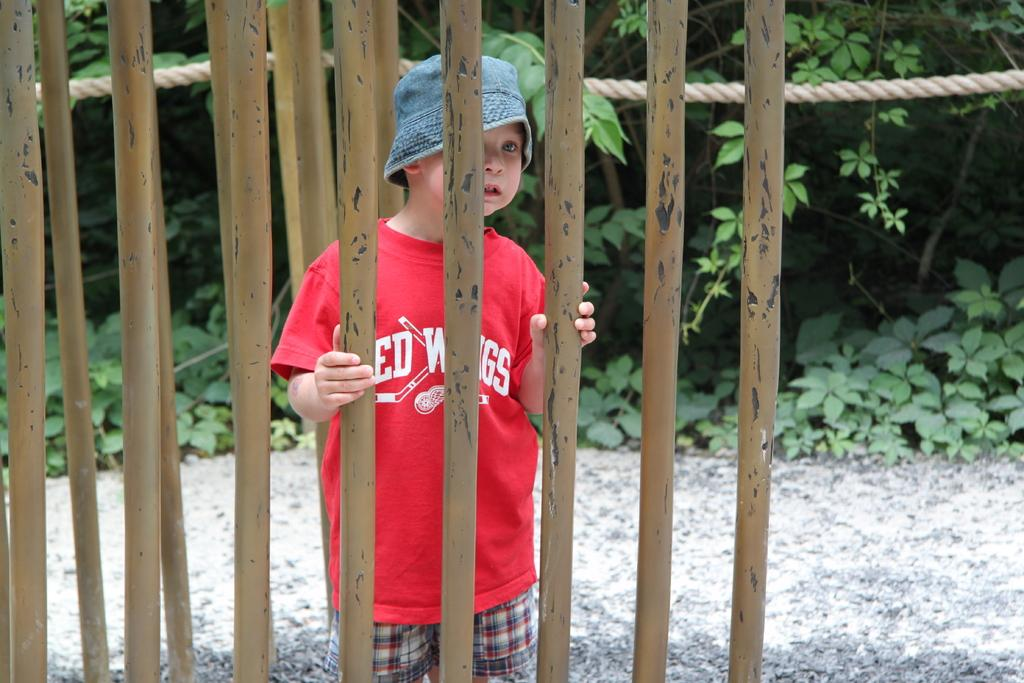What is the main subject of the image? There is a person standing in the image. What objects are present in the image besides the person? There are iron poles and a rope in the image. What can be seen in the background of the image? There are trees in the background of the image. How many giants can be seen in the image? There are no giants present in the image. What part of the body is used to join the rope and the iron poles in the image? The image does not show any action of joining the rope and the iron poles, so it is not possible to determine which part of the body would be used. 